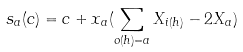<formula> <loc_0><loc_0><loc_500><loc_500>s _ { a } ( c ) = c + x _ { a } ( \sum _ { o ( h ) = a } X _ { i ( h ) } - 2 X _ { a } )</formula> 